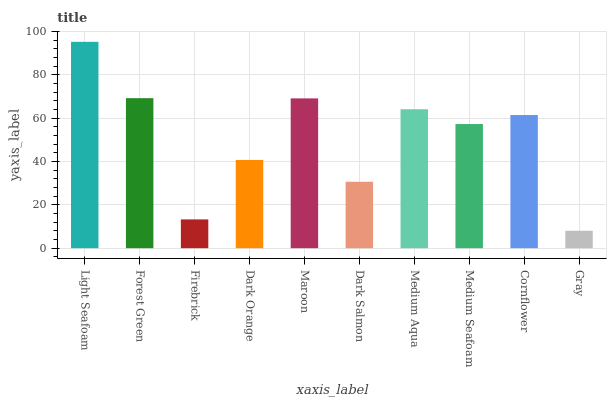Is Forest Green the minimum?
Answer yes or no. No. Is Forest Green the maximum?
Answer yes or no. No. Is Light Seafoam greater than Forest Green?
Answer yes or no. Yes. Is Forest Green less than Light Seafoam?
Answer yes or no. Yes. Is Forest Green greater than Light Seafoam?
Answer yes or no. No. Is Light Seafoam less than Forest Green?
Answer yes or no. No. Is Cornflower the high median?
Answer yes or no. Yes. Is Medium Seafoam the low median?
Answer yes or no. Yes. Is Gray the high median?
Answer yes or no. No. Is Dark Salmon the low median?
Answer yes or no. No. 